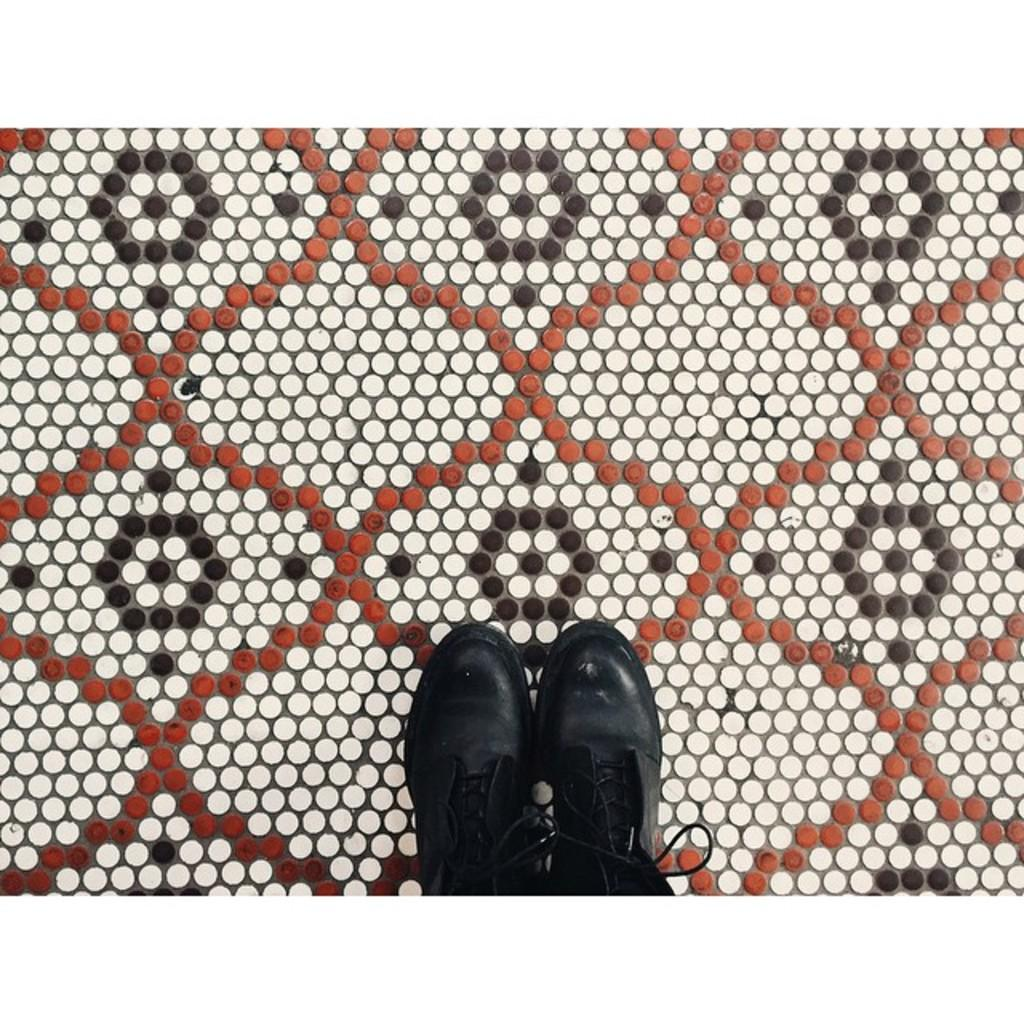What objects are on the surface in the image? There are shoes on the surface in the image. Can you see a kitty playing with the glue on the shoes in the image? There is no kitty or glue present in the image; it only features shoes on the surface. Is the heat from the sun affecting the shoes in the image? The provided facts do not mention anything about the sun or heat, so we cannot determine if the heat is affecting the shoes in the image. 